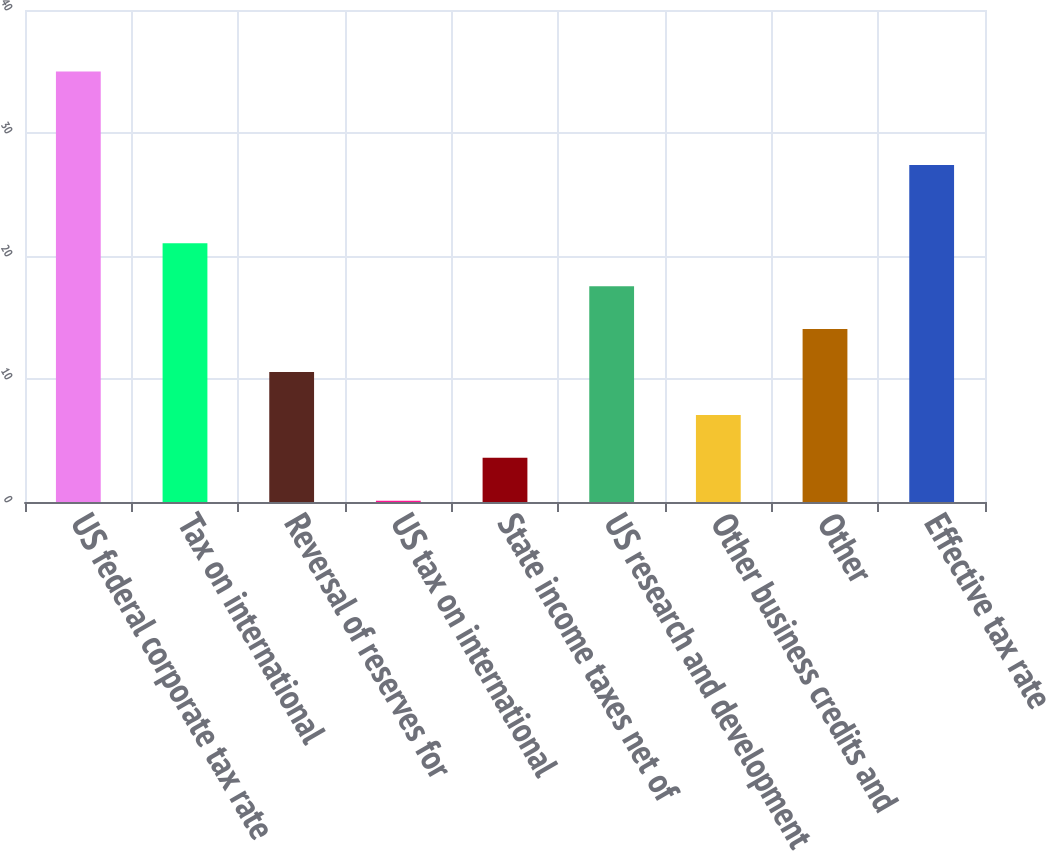Convert chart to OTSL. <chart><loc_0><loc_0><loc_500><loc_500><bar_chart><fcel>US federal corporate tax rate<fcel>Tax on international<fcel>Reversal of reserves for<fcel>US tax on international<fcel>State income taxes net of<fcel>US research and development<fcel>Other business credits and<fcel>Other<fcel>Effective tax rate<nl><fcel>35<fcel>21.04<fcel>10.57<fcel>0.1<fcel>3.59<fcel>17.55<fcel>7.08<fcel>14.06<fcel>27.4<nl></chart> 